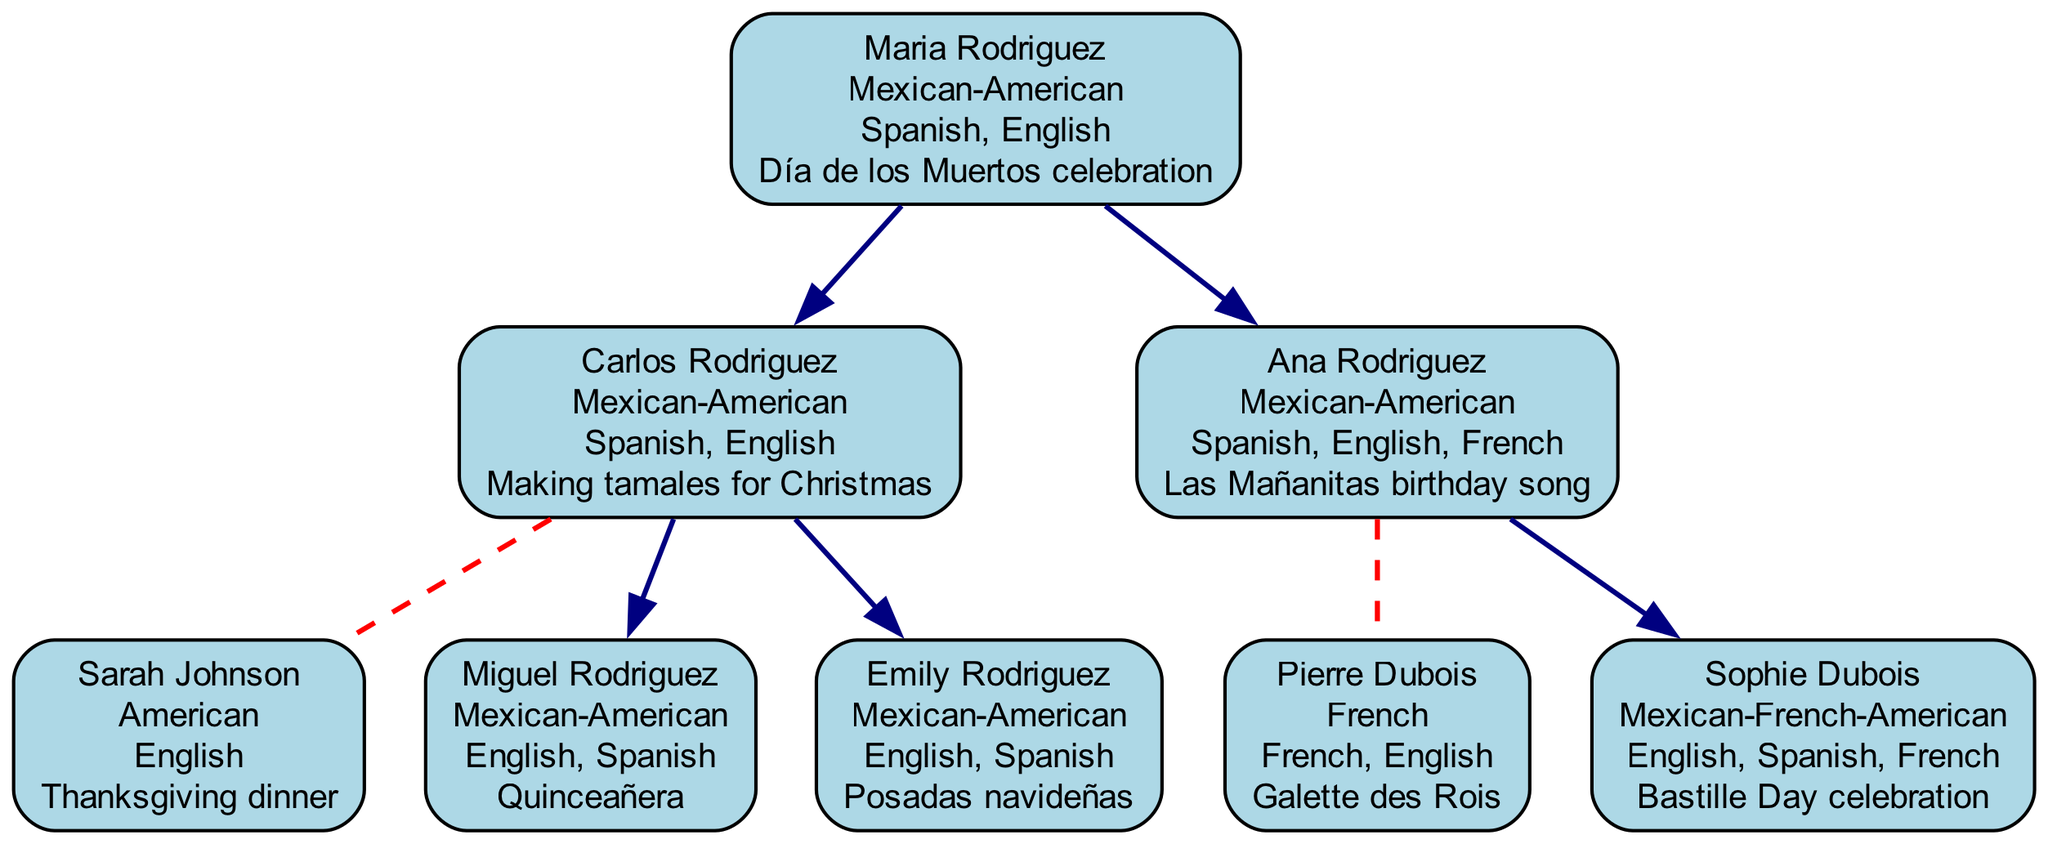What is the culture of the root member? The root member is "Maria Rodriguez," and her culture is "Mexican-American."
Answer: Mexican-American How many children does Carlos Rodriguez have? Looking under "Carlos Rodriguez," there are two listed children: "Miguel Rodriguez" and "Emily Rodriguez."
Answer: 2 What language does Sophie Dubois speak? Under "Sophie Dubois," the languages listed are "English, Spanish, French." The answer is derived by referencing her node.
Answer: English, Spanish, French Which tradition is associated with Maria Rodriguez? In the diagram, for "Maria Rodriguez," the tradition listed is "Día de los Muertos celebration."
Answer: Día de los Muertos celebration What is the relationship between Pierre Dubois and Ana Rodriguez? Pierre Dubois is listed as the spouse of "Ana Rodriguez," indicating they are married.
Answer: Spouse How many total generations are represented in the family tree? The tree has "Maria Rodriguez" at the root (1st generation), her children (2nd generation), and her grandchildren (3rd generation), indicating a total of three generations.
Answer: 3 What cultural tradition doesEmily Rodriguez observe? Under "Emily Rodriguez," her tradition presented is "Posadas navideñas." This is found by referring to her node directly.
Answer: Posadas navideñas Which member has the Thanksgiving dinner tradition? The member who has the "Thanksgiving dinner" tradition is "Sarah Johnson," who is the spouse of "Carlos Rodriguez." This is determined by checking the corresponding spouse node.
Answer: Sarah Johnson How many languages are spoken by the children of Carlos Rodriguez? Carlos Rodriguez has two children, "Miguel Rodriguez" and "Emily Rodriguez," both speaking "English, Spanish." The number of unique languages spoken by both children is two.
Answer: 2 